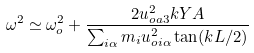<formula> <loc_0><loc_0><loc_500><loc_500>\omega ^ { 2 } \simeq \omega _ { o } ^ { 2 } + \frac { 2 u _ { o a 3 } ^ { 2 } k Y A } { \sum _ { i \alpha } m _ { i } u _ { o i \alpha } ^ { 2 } \tan ( k L / 2 ) }</formula> 